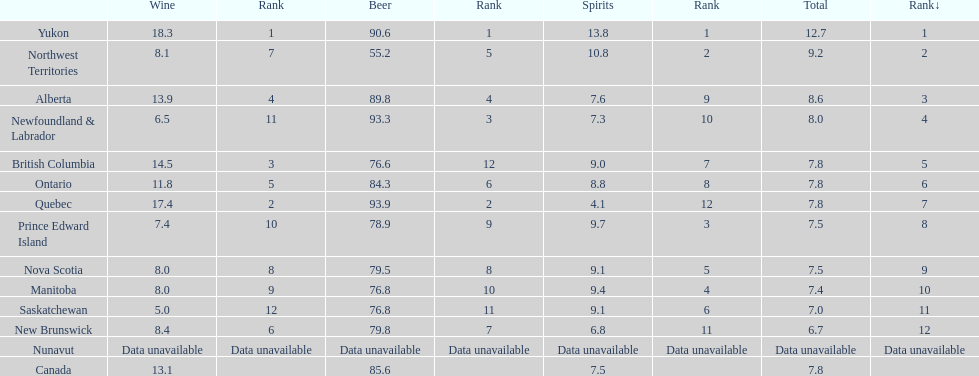Where is the highest per capita consumption of spirits annually? Yukon. What is the yearly average amount in liters that people in this area consume? 12.7. 